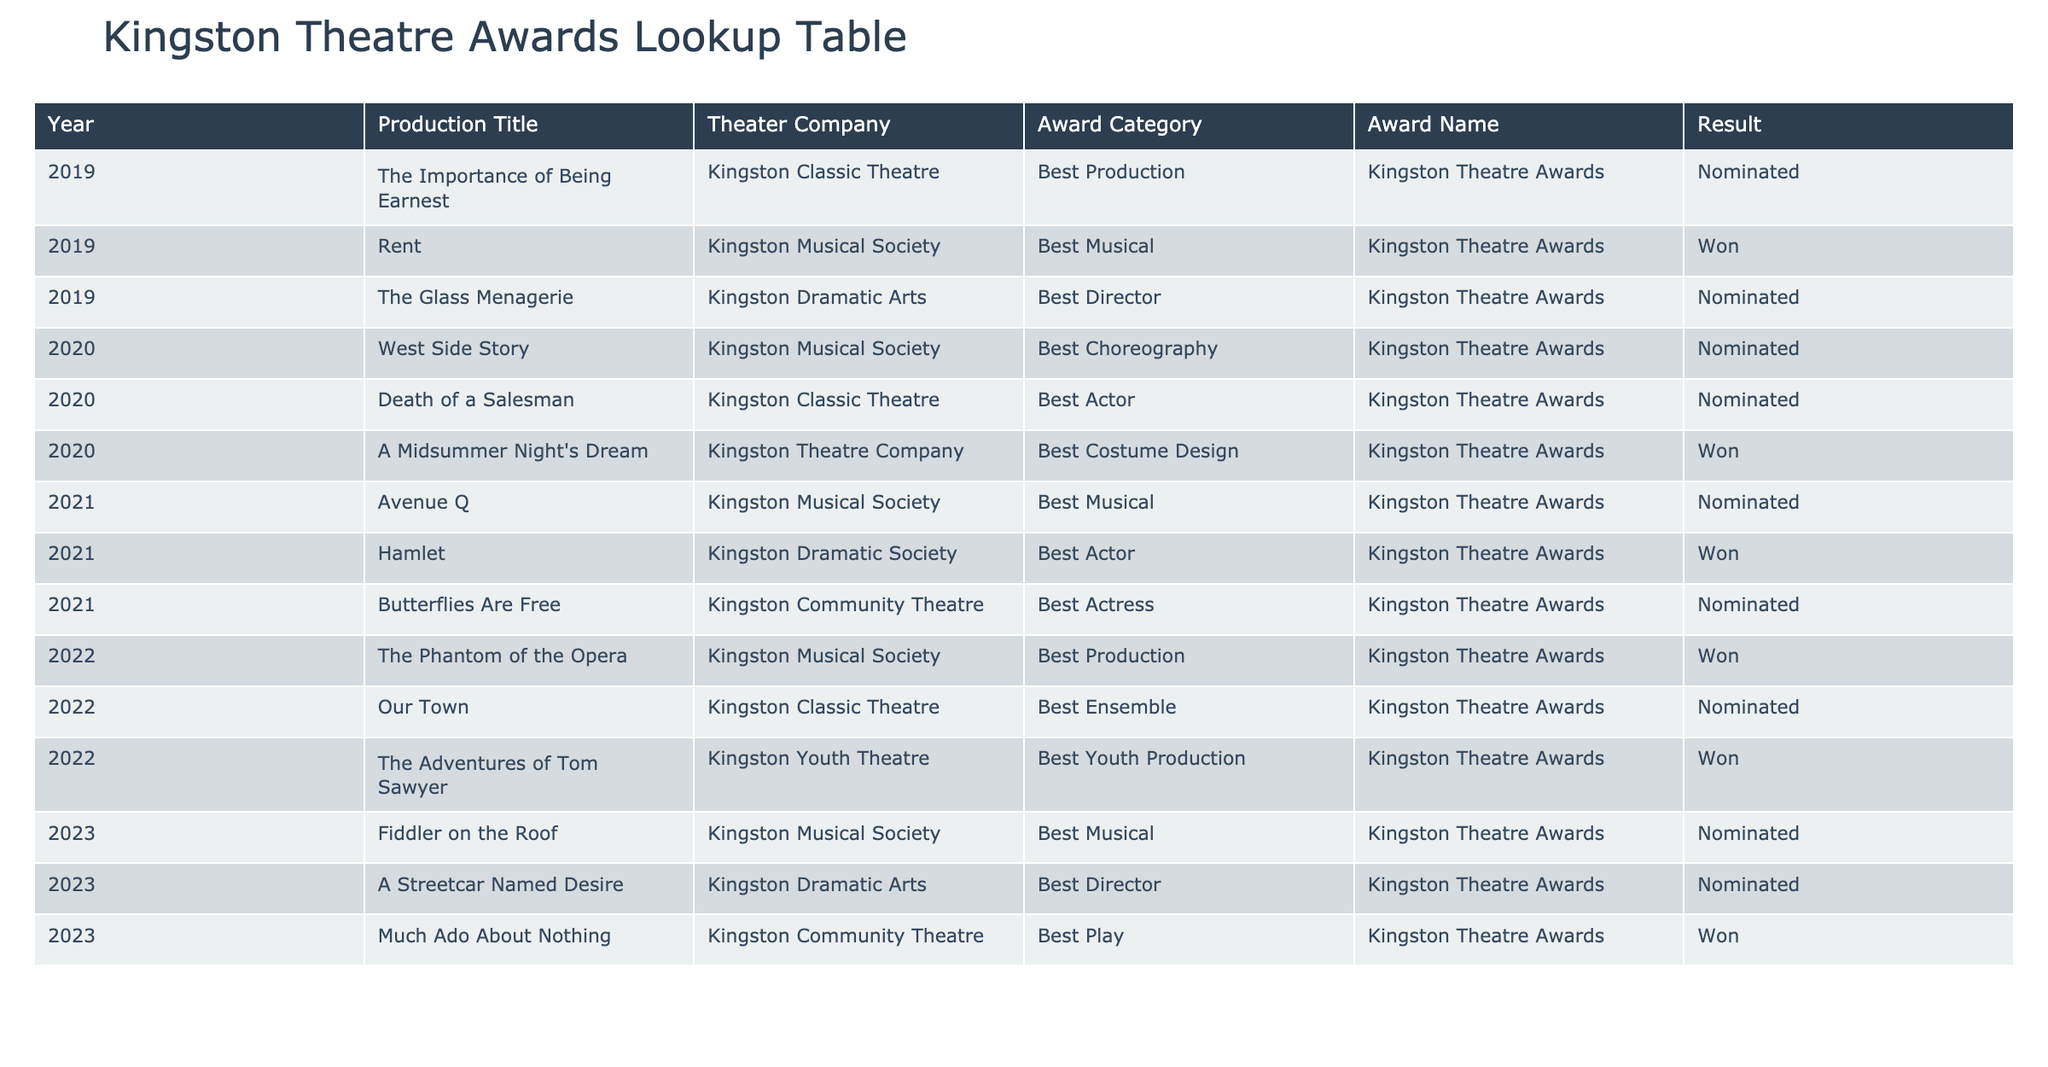What production won the Best Musical award in 2019? The table lists the productions along with their award results. In the year 2019, the production titled "Rent" by Kingston Musical Society is indicated to have won the Best Musical award.
Answer: Rent How many productions were nominated for Best Director from 2019 to 2023? The table shows nominations for Best Director in various years. In 2019, there was one nomination (The Glass Menagerie), in 2020 there were none, in 2021 there was one (Hamlet), in 2022 there were none, and in 2023 there is one nomination (A Streetcar Named Desire). Summing these gives a total of 3 nominations.
Answer: 3 Did Kingston Classic Theatre win any awards in 2020? By examining the table for 2020, the production "Death of a Salesman" was nominated for an award, but does not show any wins. Therefore, Kingston Classic Theatre did not win any awards that year.
Answer: No Which theater company had the most wins for Best Production? Looking through the table for the Best Production category, Kingston Musical Society won the award in 2019 and 2022, Kingston Classic Theatre lost a nomination in 2019, and Kingston Dramatic Arts lost a nomination in 2020. Thus, Kingston Musical Society has the highest number of wins (2).
Answer: Kingston Musical Society What was the total number of awards won by Kingston Musical Society till 2023? To determine the total wins, look through the table for Kingston Musical Society and count the awarded entries: they won Best Musical in 2019 and 2022, with a total of 2 wins.
Answer: 2 How many different productions won awards overall from 2019 to 2023? Counting the titles in the “Production Title” column of the table that show a “Won” result gives us a total of 5 different productions: "Rent", "A Midsummer Night's Dream", "Hamlet", "The Phantom of the Opera", and "Much Ado About Nothing".
Answer: 5 Was there any year in which no awards were won? A review of the table indicates that in every year from 2019 to 2023, at least one production won an award. Thus, no year went without a win.
Answer: No What is the average number of nominations per year for the Kingston Theatre Awards from 2019 to 2023? By counting all the nominations, we see there are 12 nominations over 5 years (2019-2023). Thus, the average is calculated as 12 nominations / 5 years = 2.4 nominations per year.
Answer: 2.4 